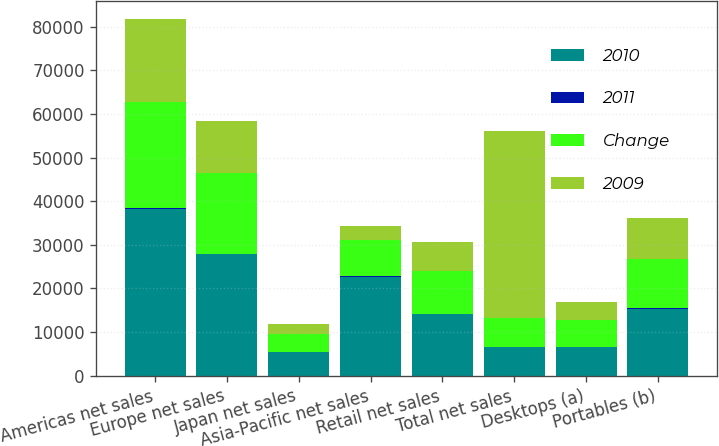Convert chart to OTSL. <chart><loc_0><loc_0><loc_500><loc_500><stacked_bar_chart><ecel><fcel>Americas net sales<fcel>Europe net sales<fcel>Japan net sales<fcel>Asia-Pacific net sales<fcel>Retail net sales<fcel>Total net sales<fcel>Desktops (a)<fcel>Portables (b)<nl><fcel>2010<fcel>38315<fcel>27778<fcel>5437<fcel>22592<fcel>14127<fcel>6547.5<fcel>6439<fcel>15344<nl><fcel>2011<fcel>56<fcel>49<fcel>37<fcel>174<fcel>44<fcel>66<fcel>4<fcel>36<nl><fcel>Change<fcel>24498<fcel>18692<fcel>3981<fcel>8256<fcel>9798<fcel>6547.5<fcel>6201<fcel>11278<nl><fcel>2009<fcel>18981<fcel>11810<fcel>2279<fcel>3179<fcel>6656<fcel>42905<fcel>4324<fcel>9535<nl></chart> 